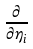<formula> <loc_0><loc_0><loc_500><loc_500>\frac { \partial } { \partial \eta _ { i } }</formula> 